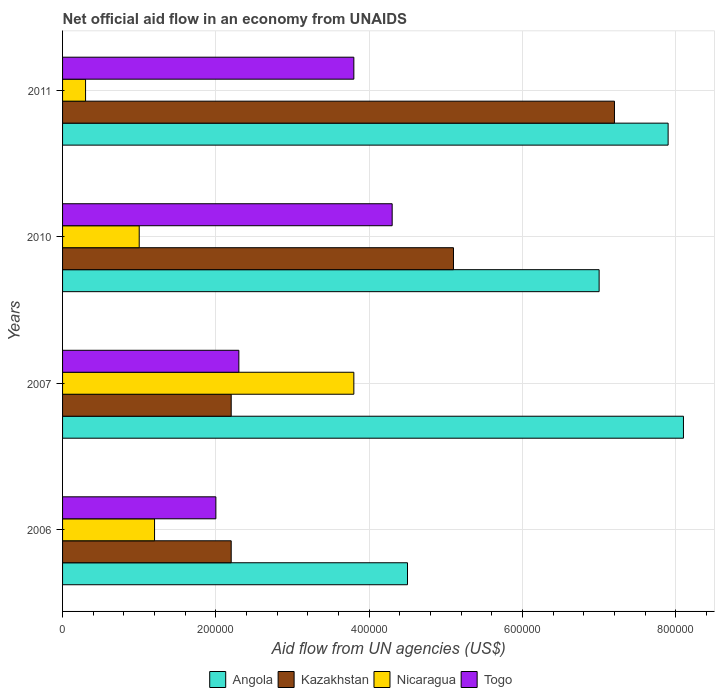Are the number of bars on each tick of the Y-axis equal?
Provide a short and direct response. Yes. In how many cases, is the number of bars for a given year not equal to the number of legend labels?
Your answer should be compact. 0. What is the net official aid flow in Nicaragua in 2007?
Offer a terse response. 3.80e+05. Across all years, what is the maximum net official aid flow in Togo?
Offer a terse response. 4.30e+05. Across all years, what is the minimum net official aid flow in Togo?
Give a very brief answer. 2.00e+05. In which year was the net official aid flow in Nicaragua minimum?
Ensure brevity in your answer.  2011. What is the total net official aid flow in Kazakhstan in the graph?
Provide a succinct answer. 1.67e+06. What is the difference between the net official aid flow in Togo in 2007 and that in 2011?
Keep it short and to the point. -1.50e+05. What is the difference between the net official aid flow in Kazakhstan in 2010 and the net official aid flow in Angola in 2007?
Ensure brevity in your answer.  -3.00e+05. What is the average net official aid flow in Kazakhstan per year?
Provide a succinct answer. 4.18e+05. In the year 2007, what is the difference between the net official aid flow in Togo and net official aid flow in Angola?
Your answer should be compact. -5.80e+05. What is the ratio of the net official aid flow in Togo in 2006 to that in 2007?
Your answer should be compact. 0.87. Is the difference between the net official aid flow in Togo in 2010 and 2011 greater than the difference between the net official aid flow in Angola in 2010 and 2011?
Provide a short and direct response. Yes. What is the difference between the highest and the lowest net official aid flow in Kazakhstan?
Give a very brief answer. 5.00e+05. In how many years, is the net official aid flow in Kazakhstan greater than the average net official aid flow in Kazakhstan taken over all years?
Offer a very short reply. 2. Is the sum of the net official aid flow in Angola in 2006 and 2010 greater than the maximum net official aid flow in Nicaragua across all years?
Make the answer very short. Yes. What does the 4th bar from the top in 2007 represents?
Keep it short and to the point. Angola. What does the 3rd bar from the bottom in 2007 represents?
Provide a succinct answer. Nicaragua. How many bars are there?
Ensure brevity in your answer.  16. Are all the bars in the graph horizontal?
Provide a short and direct response. Yes. Are the values on the major ticks of X-axis written in scientific E-notation?
Give a very brief answer. No. Does the graph contain grids?
Your answer should be very brief. Yes. Where does the legend appear in the graph?
Offer a terse response. Bottom center. How are the legend labels stacked?
Keep it short and to the point. Horizontal. What is the title of the graph?
Your response must be concise. Net official aid flow in an economy from UNAIDS. Does "Uruguay" appear as one of the legend labels in the graph?
Your answer should be compact. No. What is the label or title of the X-axis?
Provide a short and direct response. Aid flow from UN agencies (US$). What is the Aid flow from UN agencies (US$) in Angola in 2006?
Ensure brevity in your answer.  4.50e+05. What is the Aid flow from UN agencies (US$) in Kazakhstan in 2006?
Ensure brevity in your answer.  2.20e+05. What is the Aid flow from UN agencies (US$) of Togo in 2006?
Provide a succinct answer. 2.00e+05. What is the Aid flow from UN agencies (US$) in Angola in 2007?
Provide a succinct answer. 8.10e+05. What is the Aid flow from UN agencies (US$) of Nicaragua in 2007?
Your answer should be very brief. 3.80e+05. What is the Aid flow from UN agencies (US$) in Togo in 2007?
Provide a succinct answer. 2.30e+05. What is the Aid flow from UN agencies (US$) in Kazakhstan in 2010?
Provide a short and direct response. 5.10e+05. What is the Aid flow from UN agencies (US$) in Nicaragua in 2010?
Your answer should be compact. 1.00e+05. What is the Aid flow from UN agencies (US$) in Angola in 2011?
Your answer should be very brief. 7.90e+05. What is the Aid flow from UN agencies (US$) in Kazakhstan in 2011?
Your response must be concise. 7.20e+05. What is the Aid flow from UN agencies (US$) of Nicaragua in 2011?
Your response must be concise. 3.00e+04. What is the Aid flow from UN agencies (US$) of Togo in 2011?
Your response must be concise. 3.80e+05. Across all years, what is the maximum Aid flow from UN agencies (US$) of Angola?
Your answer should be compact. 8.10e+05. Across all years, what is the maximum Aid flow from UN agencies (US$) of Kazakhstan?
Give a very brief answer. 7.20e+05. Across all years, what is the minimum Aid flow from UN agencies (US$) of Angola?
Offer a terse response. 4.50e+05. Across all years, what is the minimum Aid flow from UN agencies (US$) of Kazakhstan?
Your answer should be very brief. 2.20e+05. What is the total Aid flow from UN agencies (US$) of Angola in the graph?
Your response must be concise. 2.75e+06. What is the total Aid flow from UN agencies (US$) in Kazakhstan in the graph?
Give a very brief answer. 1.67e+06. What is the total Aid flow from UN agencies (US$) in Nicaragua in the graph?
Offer a terse response. 6.30e+05. What is the total Aid flow from UN agencies (US$) in Togo in the graph?
Your response must be concise. 1.24e+06. What is the difference between the Aid flow from UN agencies (US$) of Angola in 2006 and that in 2007?
Give a very brief answer. -3.60e+05. What is the difference between the Aid flow from UN agencies (US$) in Angola in 2006 and that in 2010?
Your answer should be very brief. -2.50e+05. What is the difference between the Aid flow from UN agencies (US$) of Kazakhstan in 2006 and that in 2010?
Your answer should be compact. -2.90e+05. What is the difference between the Aid flow from UN agencies (US$) in Nicaragua in 2006 and that in 2010?
Keep it short and to the point. 2.00e+04. What is the difference between the Aid flow from UN agencies (US$) of Togo in 2006 and that in 2010?
Your answer should be compact. -2.30e+05. What is the difference between the Aid flow from UN agencies (US$) in Angola in 2006 and that in 2011?
Keep it short and to the point. -3.40e+05. What is the difference between the Aid flow from UN agencies (US$) in Kazakhstan in 2006 and that in 2011?
Provide a succinct answer. -5.00e+05. What is the difference between the Aid flow from UN agencies (US$) in Nicaragua in 2006 and that in 2011?
Provide a succinct answer. 9.00e+04. What is the difference between the Aid flow from UN agencies (US$) of Angola in 2007 and that in 2010?
Offer a very short reply. 1.10e+05. What is the difference between the Aid flow from UN agencies (US$) in Kazakhstan in 2007 and that in 2010?
Your answer should be very brief. -2.90e+05. What is the difference between the Aid flow from UN agencies (US$) of Nicaragua in 2007 and that in 2010?
Provide a succinct answer. 2.80e+05. What is the difference between the Aid flow from UN agencies (US$) of Angola in 2007 and that in 2011?
Your answer should be very brief. 2.00e+04. What is the difference between the Aid flow from UN agencies (US$) of Kazakhstan in 2007 and that in 2011?
Ensure brevity in your answer.  -5.00e+05. What is the difference between the Aid flow from UN agencies (US$) in Nicaragua in 2007 and that in 2011?
Provide a succinct answer. 3.50e+05. What is the difference between the Aid flow from UN agencies (US$) in Togo in 2007 and that in 2011?
Your answer should be compact. -1.50e+05. What is the difference between the Aid flow from UN agencies (US$) in Kazakhstan in 2010 and that in 2011?
Make the answer very short. -2.10e+05. What is the difference between the Aid flow from UN agencies (US$) of Nicaragua in 2010 and that in 2011?
Offer a very short reply. 7.00e+04. What is the difference between the Aid flow from UN agencies (US$) in Togo in 2010 and that in 2011?
Provide a short and direct response. 5.00e+04. What is the difference between the Aid flow from UN agencies (US$) of Angola in 2006 and the Aid flow from UN agencies (US$) of Kazakhstan in 2007?
Your answer should be compact. 2.30e+05. What is the difference between the Aid flow from UN agencies (US$) of Angola in 2006 and the Aid flow from UN agencies (US$) of Nicaragua in 2007?
Offer a terse response. 7.00e+04. What is the difference between the Aid flow from UN agencies (US$) in Angola in 2006 and the Aid flow from UN agencies (US$) in Togo in 2007?
Your answer should be very brief. 2.20e+05. What is the difference between the Aid flow from UN agencies (US$) in Angola in 2006 and the Aid flow from UN agencies (US$) in Kazakhstan in 2010?
Make the answer very short. -6.00e+04. What is the difference between the Aid flow from UN agencies (US$) of Angola in 2006 and the Aid flow from UN agencies (US$) of Togo in 2010?
Your answer should be compact. 2.00e+04. What is the difference between the Aid flow from UN agencies (US$) of Nicaragua in 2006 and the Aid flow from UN agencies (US$) of Togo in 2010?
Ensure brevity in your answer.  -3.10e+05. What is the difference between the Aid flow from UN agencies (US$) of Angola in 2006 and the Aid flow from UN agencies (US$) of Kazakhstan in 2011?
Give a very brief answer. -2.70e+05. What is the difference between the Aid flow from UN agencies (US$) of Angola in 2006 and the Aid flow from UN agencies (US$) of Nicaragua in 2011?
Offer a very short reply. 4.20e+05. What is the difference between the Aid flow from UN agencies (US$) in Kazakhstan in 2006 and the Aid flow from UN agencies (US$) in Nicaragua in 2011?
Make the answer very short. 1.90e+05. What is the difference between the Aid flow from UN agencies (US$) of Kazakhstan in 2006 and the Aid flow from UN agencies (US$) of Togo in 2011?
Make the answer very short. -1.60e+05. What is the difference between the Aid flow from UN agencies (US$) of Angola in 2007 and the Aid flow from UN agencies (US$) of Nicaragua in 2010?
Ensure brevity in your answer.  7.10e+05. What is the difference between the Aid flow from UN agencies (US$) in Angola in 2007 and the Aid flow from UN agencies (US$) in Togo in 2010?
Keep it short and to the point. 3.80e+05. What is the difference between the Aid flow from UN agencies (US$) in Kazakhstan in 2007 and the Aid flow from UN agencies (US$) in Togo in 2010?
Your answer should be compact. -2.10e+05. What is the difference between the Aid flow from UN agencies (US$) in Nicaragua in 2007 and the Aid flow from UN agencies (US$) in Togo in 2010?
Your answer should be very brief. -5.00e+04. What is the difference between the Aid flow from UN agencies (US$) of Angola in 2007 and the Aid flow from UN agencies (US$) of Kazakhstan in 2011?
Offer a very short reply. 9.00e+04. What is the difference between the Aid flow from UN agencies (US$) in Angola in 2007 and the Aid flow from UN agencies (US$) in Nicaragua in 2011?
Offer a terse response. 7.80e+05. What is the difference between the Aid flow from UN agencies (US$) of Angola in 2007 and the Aid flow from UN agencies (US$) of Togo in 2011?
Your response must be concise. 4.30e+05. What is the difference between the Aid flow from UN agencies (US$) in Nicaragua in 2007 and the Aid flow from UN agencies (US$) in Togo in 2011?
Your answer should be very brief. 0. What is the difference between the Aid flow from UN agencies (US$) of Angola in 2010 and the Aid flow from UN agencies (US$) of Kazakhstan in 2011?
Make the answer very short. -2.00e+04. What is the difference between the Aid flow from UN agencies (US$) in Angola in 2010 and the Aid flow from UN agencies (US$) in Nicaragua in 2011?
Provide a succinct answer. 6.70e+05. What is the difference between the Aid flow from UN agencies (US$) of Kazakhstan in 2010 and the Aid flow from UN agencies (US$) of Togo in 2011?
Ensure brevity in your answer.  1.30e+05. What is the difference between the Aid flow from UN agencies (US$) in Nicaragua in 2010 and the Aid flow from UN agencies (US$) in Togo in 2011?
Your answer should be very brief. -2.80e+05. What is the average Aid flow from UN agencies (US$) of Angola per year?
Give a very brief answer. 6.88e+05. What is the average Aid flow from UN agencies (US$) in Kazakhstan per year?
Provide a succinct answer. 4.18e+05. What is the average Aid flow from UN agencies (US$) in Nicaragua per year?
Offer a terse response. 1.58e+05. In the year 2006, what is the difference between the Aid flow from UN agencies (US$) of Angola and Aid flow from UN agencies (US$) of Nicaragua?
Your response must be concise. 3.30e+05. In the year 2006, what is the difference between the Aid flow from UN agencies (US$) in Angola and Aid flow from UN agencies (US$) in Togo?
Your response must be concise. 2.50e+05. In the year 2006, what is the difference between the Aid flow from UN agencies (US$) in Nicaragua and Aid flow from UN agencies (US$) in Togo?
Make the answer very short. -8.00e+04. In the year 2007, what is the difference between the Aid flow from UN agencies (US$) in Angola and Aid flow from UN agencies (US$) in Kazakhstan?
Your response must be concise. 5.90e+05. In the year 2007, what is the difference between the Aid flow from UN agencies (US$) of Angola and Aid flow from UN agencies (US$) of Togo?
Your answer should be very brief. 5.80e+05. In the year 2007, what is the difference between the Aid flow from UN agencies (US$) of Kazakhstan and Aid flow from UN agencies (US$) of Nicaragua?
Your answer should be very brief. -1.60e+05. In the year 2007, what is the difference between the Aid flow from UN agencies (US$) in Kazakhstan and Aid flow from UN agencies (US$) in Togo?
Offer a very short reply. -10000. In the year 2010, what is the difference between the Aid flow from UN agencies (US$) in Angola and Aid flow from UN agencies (US$) in Nicaragua?
Provide a short and direct response. 6.00e+05. In the year 2010, what is the difference between the Aid flow from UN agencies (US$) of Angola and Aid flow from UN agencies (US$) of Togo?
Offer a very short reply. 2.70e+05. In the year 2010, what is the difference between the Aid flow from UN agencies (US$) in Kazakhstan and Aid flow from UN agencies (US$) in Togo?
Ensure brevity in your answer.  8.00e+04. In the year 2010, what is the difference between the Aid flow from UN agencies (US$) in Nicaragua and Aid flow from UN agencies (US$) in Togo?
Provide a succinct answer. -3.30e+05. In the year 2011, what is the difference between the Aid flow from UN agencies (US$) in Angola and Aid flow from UN agencies (US$) in Nicaragua?
Offer a very short reply. 7.60e+05. In the year 2011, what is the difference between the Aid flow from UN agencies (US$) in Kazakhstan and Aid flow from UN agencies (US$) in Nicaragua?
Provide a short and direct response. 6.90e+05. In the year 2011, what is the difference between the Aid flow from UN agencies (US$) of Nicaragua and Aid flow from UN agencies (US$) of Togo?
Offer a very short reply. -3.50e+05. What is the ratio of the Aid flow from UN agencies (US$) in Angola in 2006 to that in 2007?
Provide a succinct answer. 0.56. What is the ratio of the Aid flow from UN agencies (US$) in Kazakhstan in 2006 to that in 2007?
Give a very brief answer. 1. What is the ratio of the Aid flow from UN agencies (US$) of Nicaragua in 2006 to that in 2007?
Your answer should be compact. 0.32. What is the ratio of the Aid flow from UN agencies (US$) of Togo in 2006 to that in 2007?
Provide a short and direct response. 0.87. What is the ratio of the Aid flow from UN agencies (US$) of Angola in 2006 to that in 2010?
Provide a short and direct response. 0.64. What is the ratio of the Aid flow from UN agencies (US$) of Kazakhstan in 2006 to that in 2010?
Provide a succinct answer. 0.43. What is the ratio of the Aid flow from UN agencies (US$) in Nicaragua in 2006 to that in 2010?
Your answer should be compact. 1.2. What is the ratio of the Aid flow from UN agencies (US$) in Togo in 2006 to that in 2010?
Your answer should be compact. 0.47. What is the ratio of the Aid flow from UN agencies (US$) in Angola in 2006 to that in 2011?
Provide a succinct answer. 0.57. What is the ratio of the Aid flow from UN agencies (US$) of Kazakhstan in 2006 to that in 2011?
Ensure brevity in your answer.  0.31. What is the ratio of the Aid flow from UN agencies (US$) in Nicaragua in 2006 to that in 2011?
Your answer should be compact. 4. What is the ratio of the Aid flow from UN agencies (US$) of Togo in 2006 to that in 2011?
Your answer should be compact. 0.53. What is the ratio of the Aid flow from UN agencies (US$) of Angola in 2007 to that in 2010?
Your answer should be very brief. 1.16. What is the ratio of the Aid flow from UN agencies (US$) in Kazakhstan in 2007 to that in 2010?
Ensure brevity in your answer.  0.43. What is the ratio of the Aid flow from UN agencies (US$) in Togo in 2007 to that in 2010?
Offer a very short reply. 0.53. What is the ratio of the Aid flow from UN agencies (US$) in Angola in 2007 to that in 2011?
Keep it short and to the point. 1.03. What is the ratio of the Aid flow from UN agencies (US$) in Kazakhstan in 2007 to that in 2011?
Your response must be concise. 0.31. What is the ratio of the Aid flow from UN agencies (US$) of Nicaragua in 2007 to that in 2011?
Ensure brevity in your answer.  12.67. What is the ratio of the Aid flow from UN agencies (US$) in Togo in 2007 to that in 2011?
Your answer should be compact. 0.61. What is the ratio of the Aid flow from UN agencies (US$) of Angola in 2010 to that in 2011?
Your response must be concise. 0.89. What is the ratio of the Aid flow from UN agencies (US$) of Kazakhstan in 2010 to that in 2011?
Provide a short and direct response. 0.71. What is the ratio of the Aid flow from UN agencies (US$) of Togo in 2010 to that in 2011?
Give a very brief answer. 1.13. What is the difference between the highest and the second highest Aid flow from UN agencies (US$) in Angola?
Give a very brief answer. 2.00e+04. What is the difference between the highest and the second highest Aid flow from UN agencies (US$) in Kazakhstan?
Provide a short and direct response. 2.10e+05. What is the difference between the highest and the second highest Aid flow from UN agencies (US$) of Togo?
Your response must be concise. 5.00e+04. What is the difference between the highest and the lowest Aid flow from UN agencies (US$) in Angola?
Offer a terse response. 3.60e+05. What is the difference between the highest and the lowest Aid flow from UN agencies (US$) of Nicaragua?
Your response must be concise. 3.50e+05. What is the difference between the highest and the lowest Aid flow from UN agencies (US$) of Togo?
Give a very brief answer. 2.30e+05. 